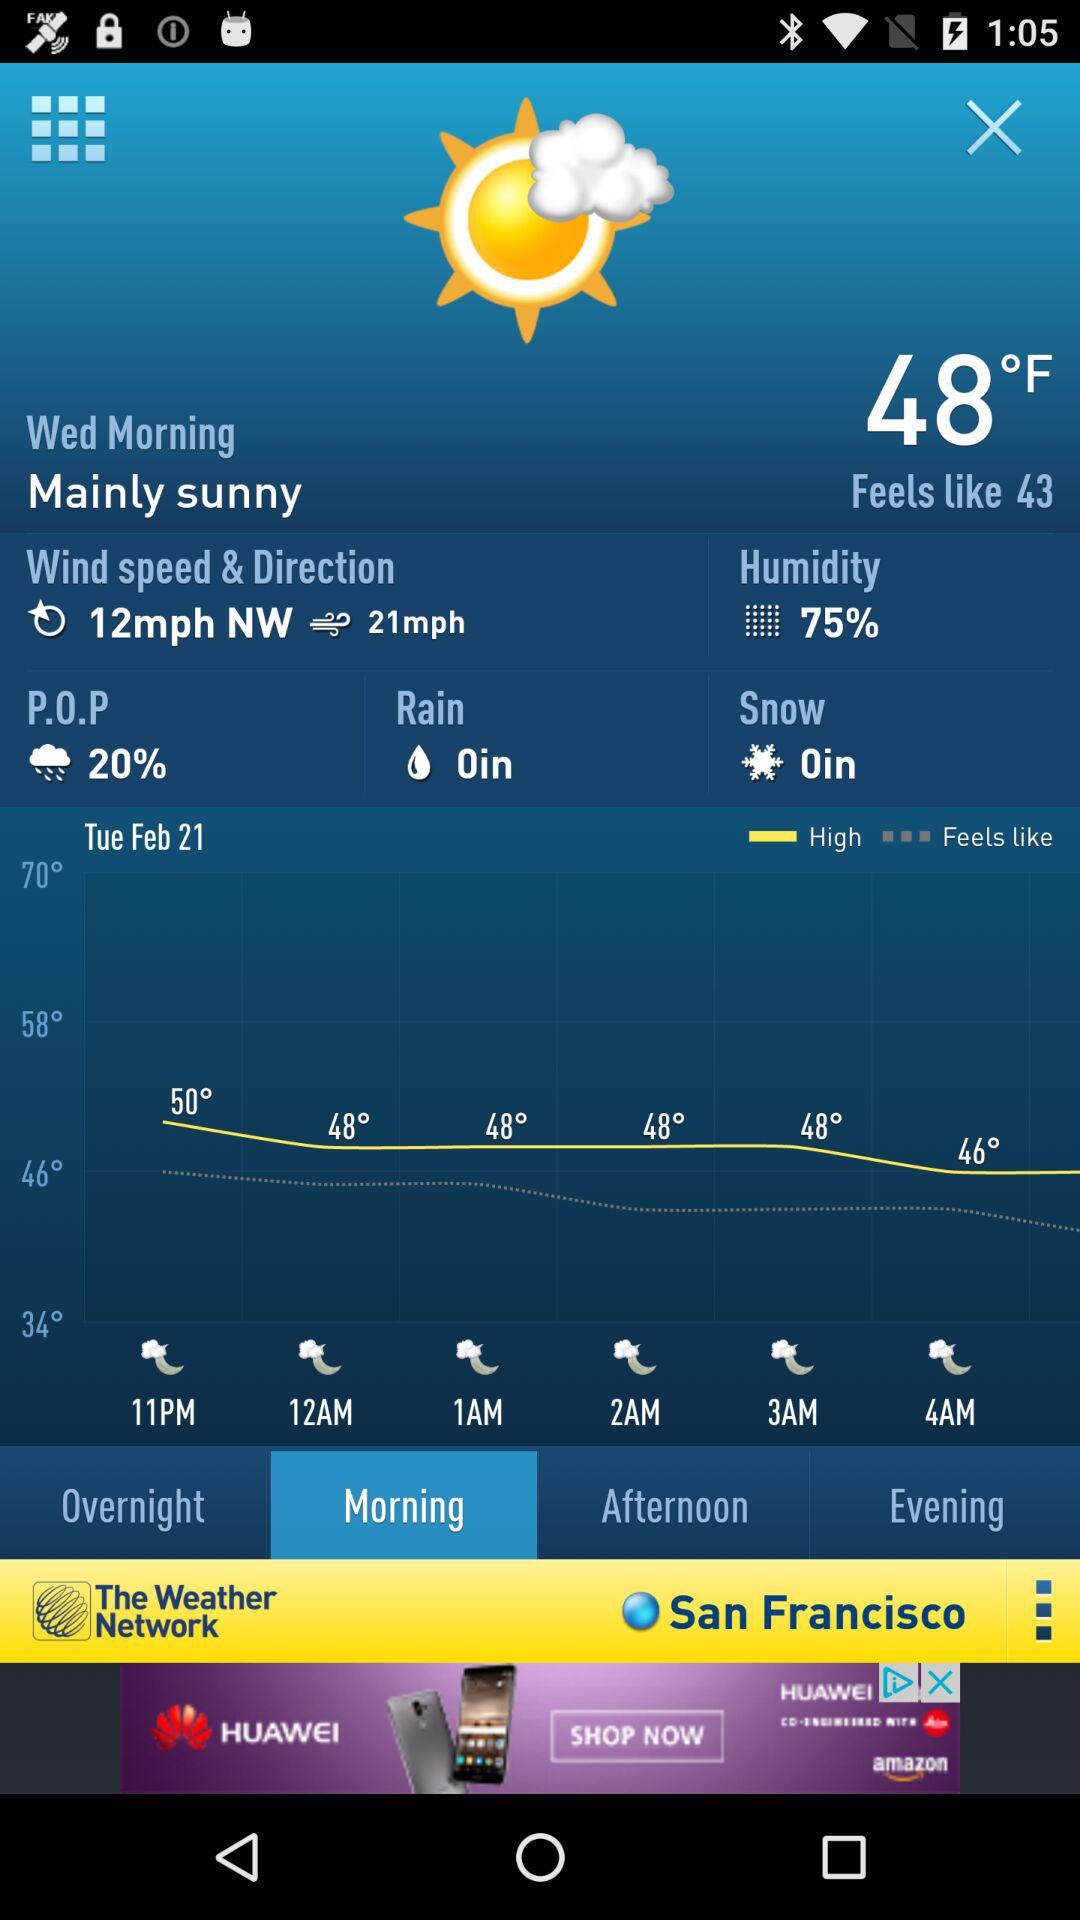What is the speed of the wind? The speeds of the wind are 12 mph and 21 mph. 